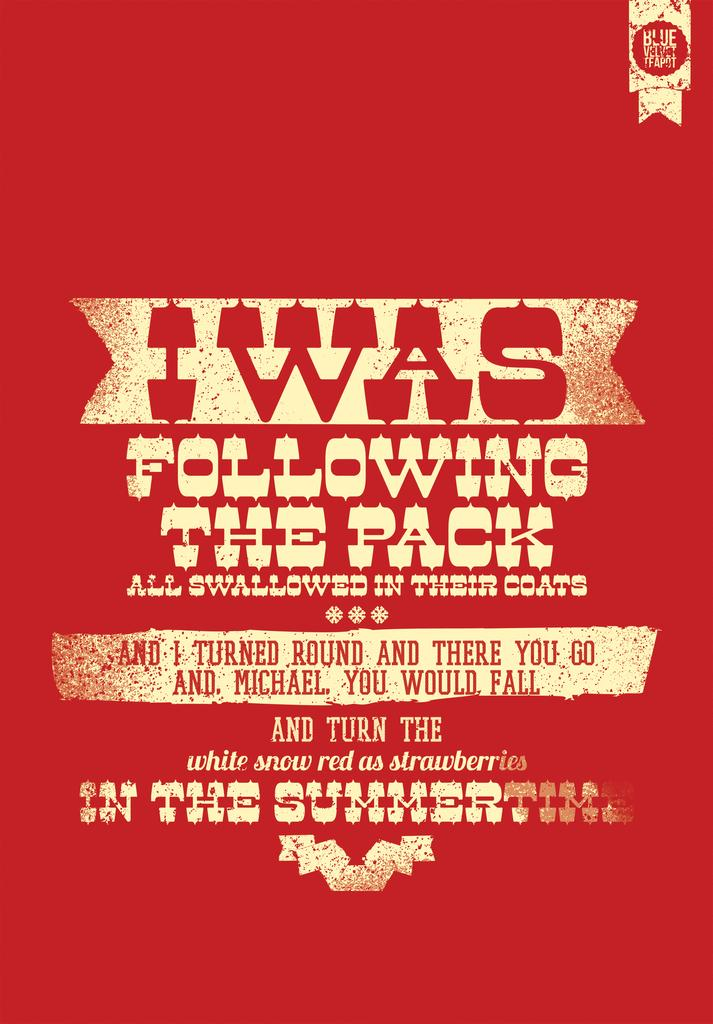Provide a one-sentence caption for the provided image. A poster for the Blue Velvet Teapot written in Old West style writing. 